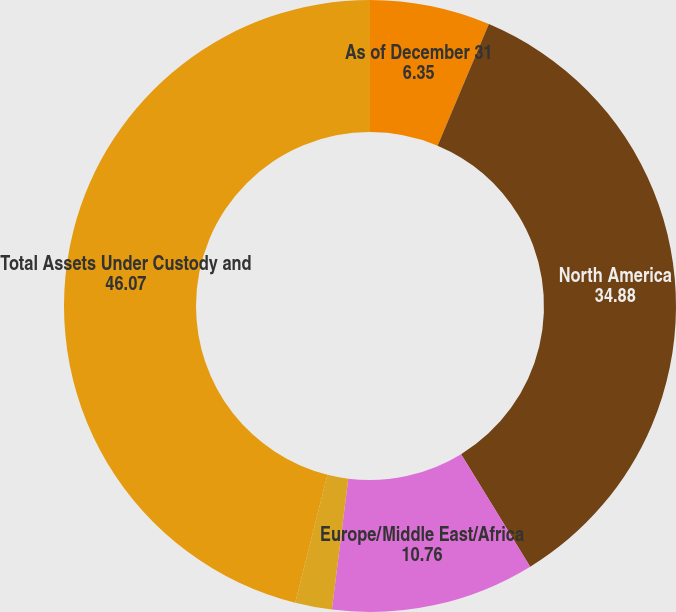Convert chart. <chart><loc_0><loc_0><loc_500><loc_500><pie_chart><fcel>As of December 31<fcel>North America<fcel>Europe/Middle East/Africa<fcel>Asia/Pacific<fcel>Total Assets Under Custody and<nl><fcel>6.35%<fcel>34.88%<fcel>10.76%<fcel>1.94%<fcel>46.07%<nl></chart> 